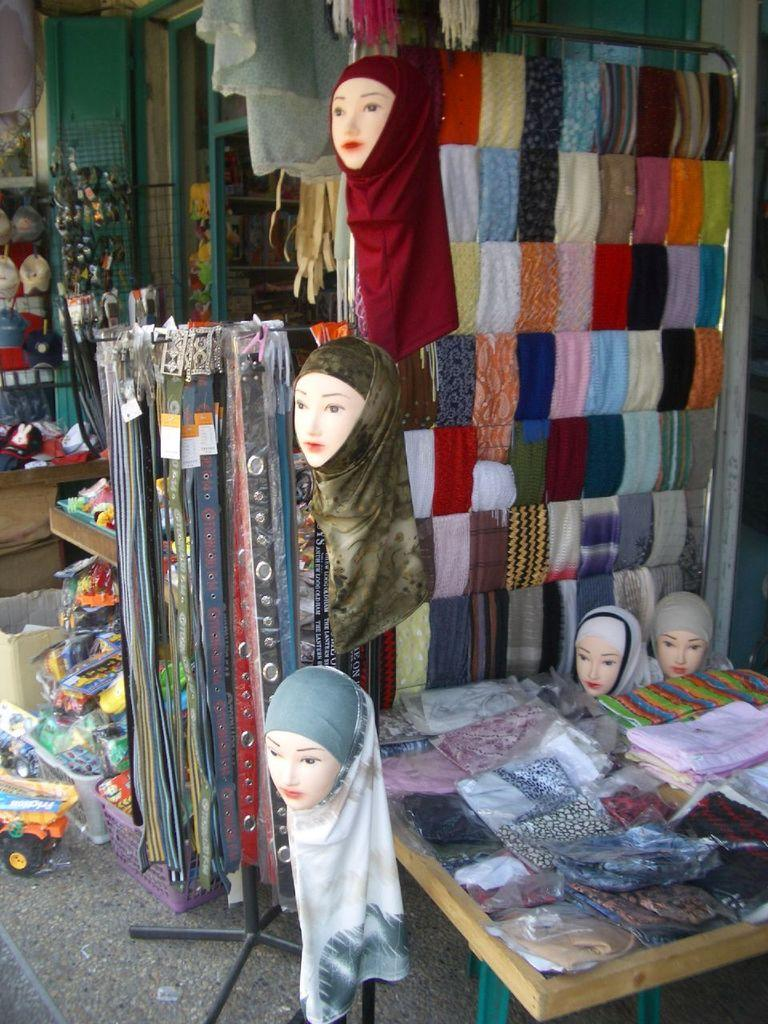What type of objects are featured on the mannequin faces in the image? The mannequin faces in the image have multi-colored clothes. What other items can be seen in the image besides the mannequin faces? Belts are visible in the image. What can be seen in the background of the image? There are multi-colored toys in the background of the image. Can you tell me how many tickets the boy is holding in the image? There is no boy present in the image, and therefore no tickets can be observed. What type of crow is sitting on the mannequin's shoulder in the image? There is no crow present in the image; it only features mannequin faces, multi-colored clothes, belts, and multi-colored toys in the background. 